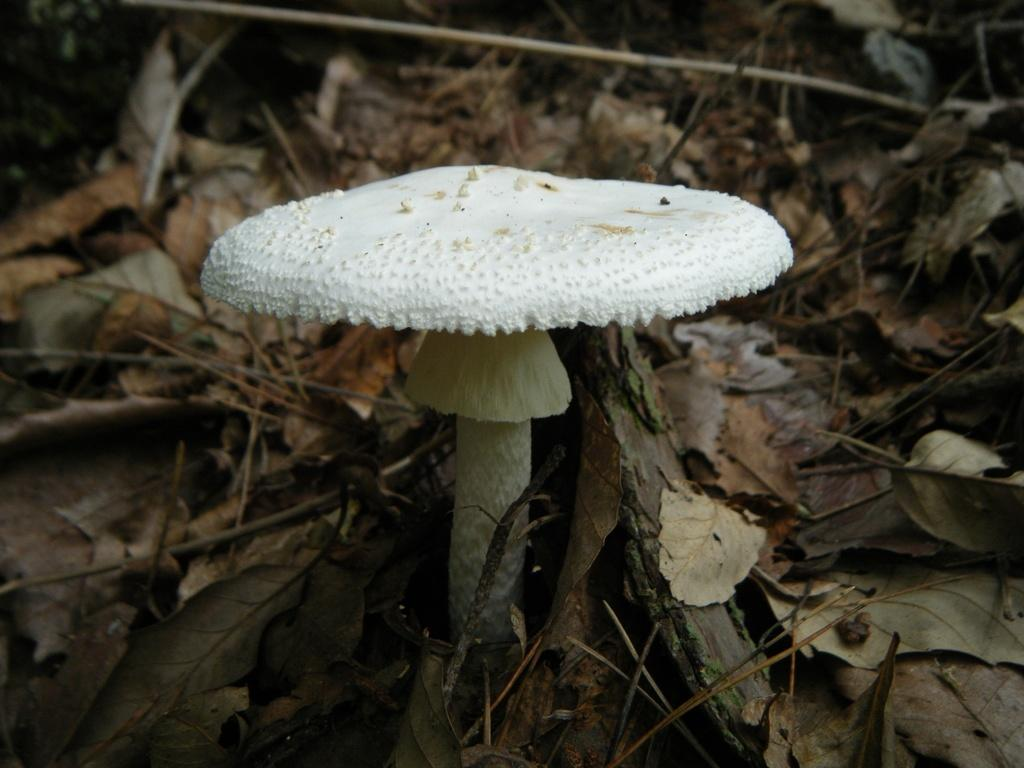What type of plant is in the image? There is a mushroom plant in the image. What color is the mushroom plant? The mushroom plant is white in color. Where is the mushroom plant located in the image? The mushroom plant is in the front of the image. What can be seen around the mushroom plant? Dry leaves surround the mushroom plant. How many books is the mushroom plant reading in the image? The mushroom plant is not reading any books in the image, as it is a plant and not capable of reading. 